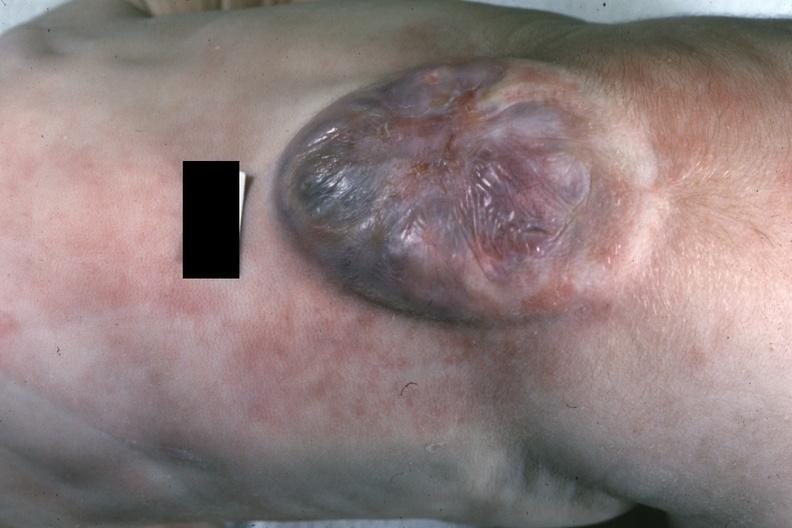what is present?
Answer the question using a single word or phrase. Spina bifida 